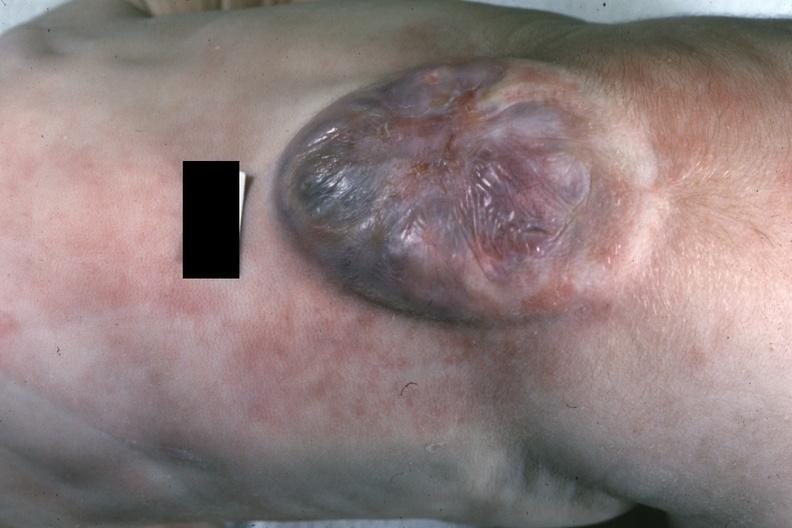what is present?
Answer the question using a single word or phrase. Spina bifida 